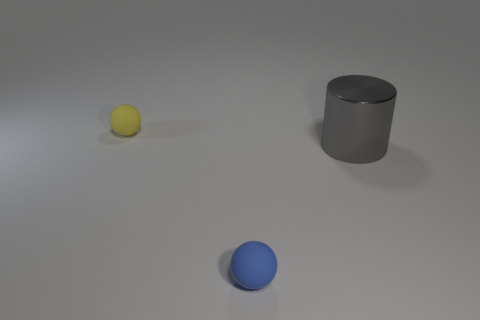What is the material of the tiny thing that is left of the tiny blue thing?
Keep it short and to the point. Rubber. There is a blue sphere that is the same material as the yellow thing; what size is it?
Provide a succinct answer. Small. Are there any small blue rubber things right of the cylinder?
Give a very brief answer. No. What is the size of the other object that is the same shape as the yellow matte thing?
Your answer should be very brief. Small. Is the color of the shiny cylinder the same as the small object that is in front of the metallic cylinder?
Your answer should be compact. No. Are there fewer big blue metallic cylinders than big metal cylinders?
Ensure brevity in your answer.  Yes. How many other things are the same color as the large cylinder?
Provide a short and direct response. 0. How many metallic cylinders are there?
Your answer should be compact. 1. Is the number of gray metal cylinders on the left side of the large gray thing less than the number of large things?
Ensure brevity in your answer.  Yes. Are the yellow thing behind the large metal cylinder and the large gray cylinder made of the same material?
Your answer should be compact. No. 